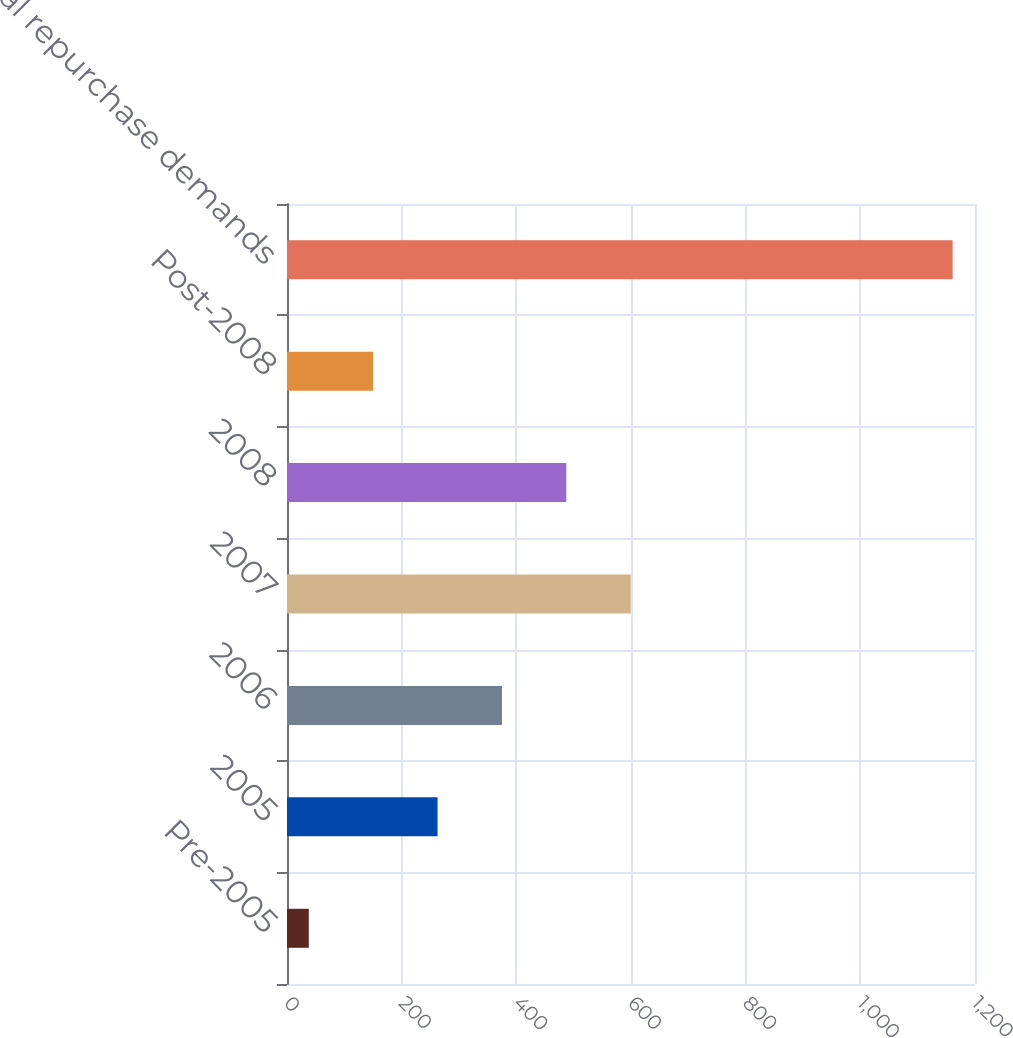Convert chart to OTSL. <chart><loc_0><loc_0><loc_500><loc_500><bar_chart><fcel>Pre-2005<fcel>2005<fcel>2006<fcel>2007<fcel>2008<fcel>Post-2008<fcel>Total repurchase demands<nl><fcel>38<fcel>262.6<fcel>374.9<fcel>599.5<fcel>487.2<fcel>150.3<fcel>1161<nl></chart> 